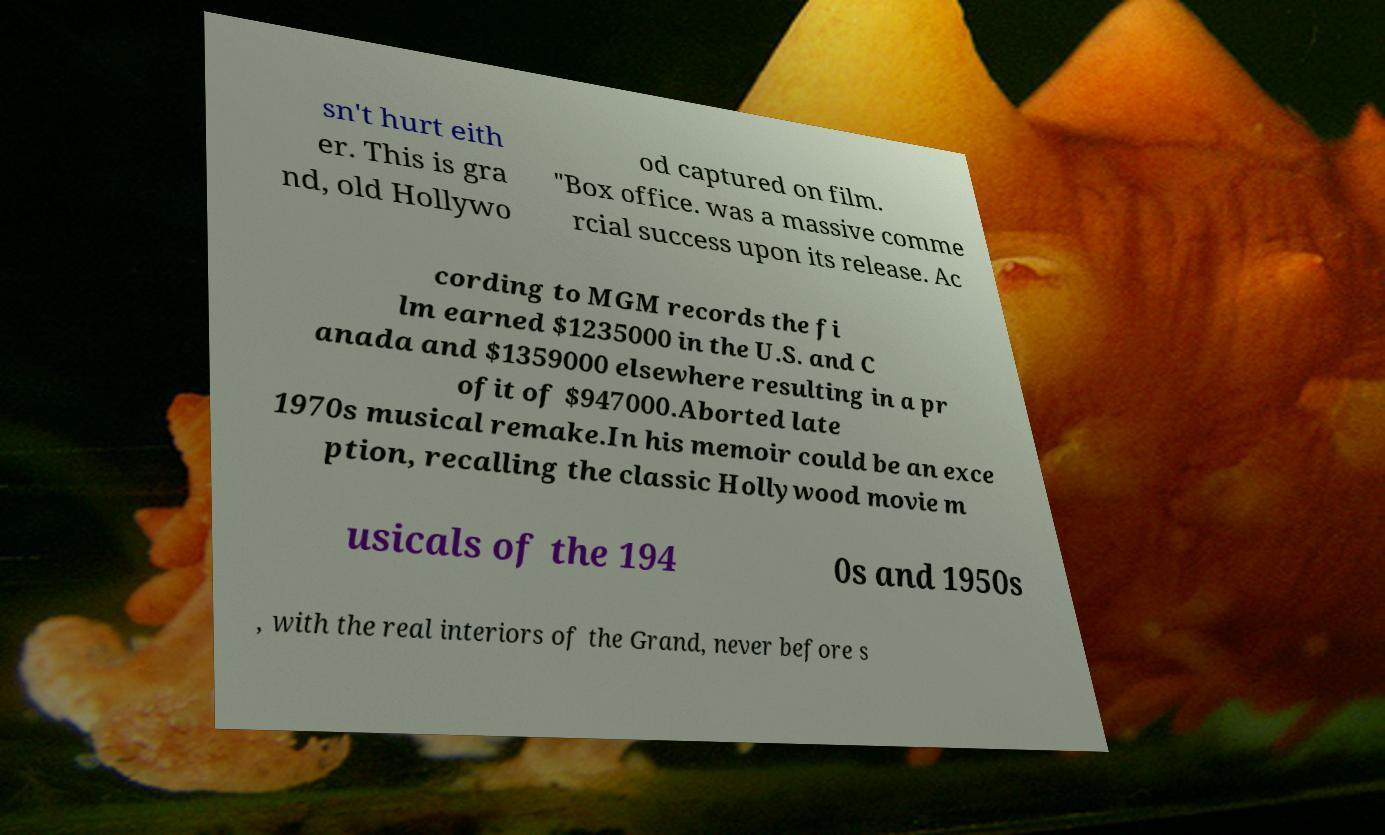Please read and relay the text visible in this image. What does it say? sn't hurt eith er. This is gra nd, old Hollywo od captured on film. "Box office. was a massive comme rcial success upon its release. Ac cording to MGM records the fi lm earned $1235000 in the U.S. and C anada and $1359000 elsewhere resulting in a pr ofit of $947000.Aborted late 1970s musical remake.In his memoir could be an exce ption, recalling the classic Hollywood movie m usicals of the 194 0s and 1950s , with the real interiors of the Grand, never before s 